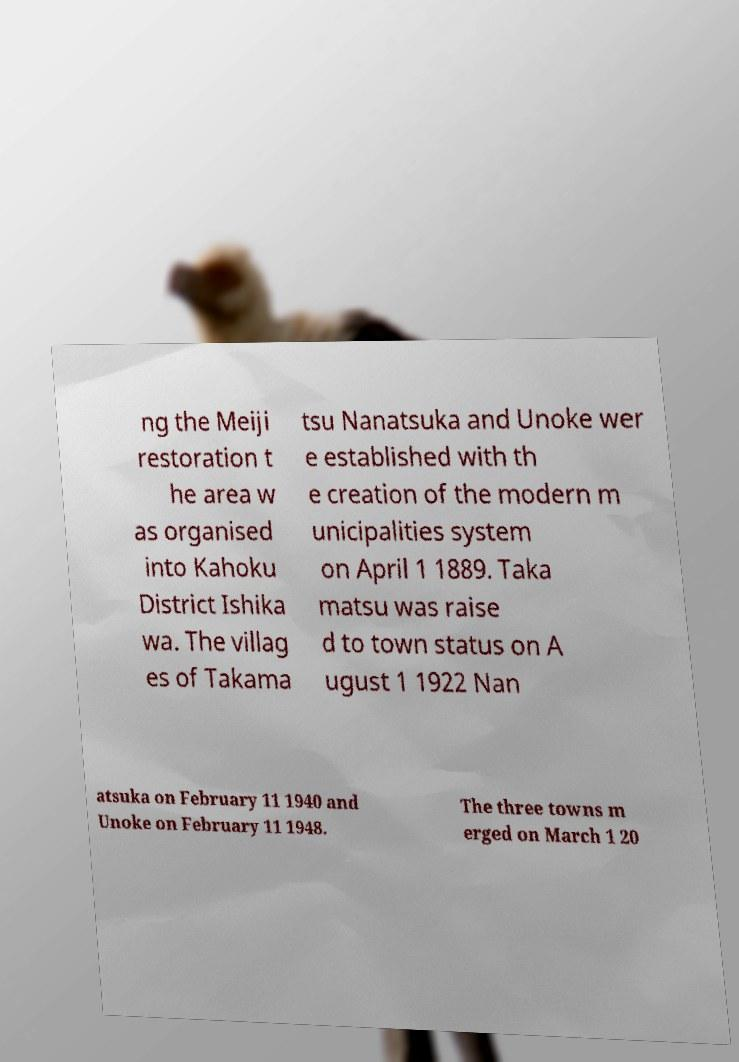Can you accurately transcribe the text from the provided image for me? ng the Meiji restoration t he area w as organised into Kahoku District Ishika wa. The villag es of Takama tsu Nanatsuka and Unoke wer e established with th e creation of the modern m unicipalities system on April 1 1889. Taka matsu was raise d to town status on A ugust 1 1922 Nan atsuka on February 11 1940 and Unoke on February 11 1948. The three towns m erged on March 1 20 